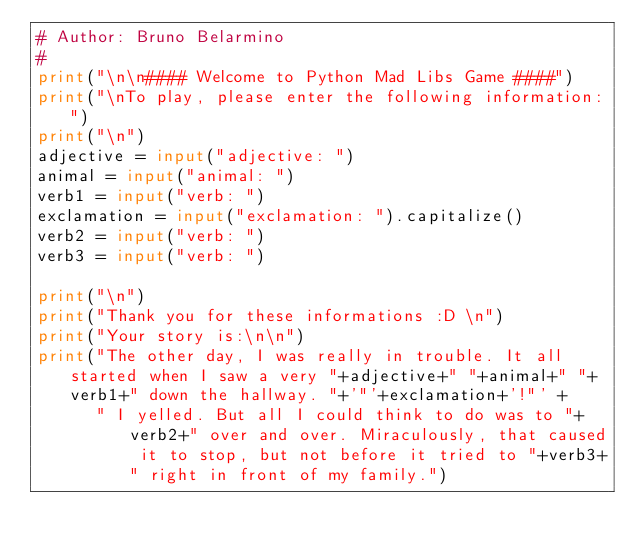<code> <loc_0><loc_0><loc_500><loc_500><_Python_># Author: Bruno Belarmino
#
print("\n\n#### Welcome to Python Mad Libs Game ####")
print("\nTo play, please enter the following information:")
print("\n")
adjective = input("adjective: ")
animal = input("animal: ")
verb1 = input("verb: ")
exclamation = input("exclamation: ").capitalize()
verb2 = input("verb: ")
verb3 = input("verb: ")

print("\n")
print("Thank you for these informations :D \n")
print("Your story is:\n\n")
print("The other day, I was really in trouble. It all started when I saw a very "+adjective+" "+animal+" "+verb1+" down the hallway. "+'"'+exclamation+'!"' +
      " I yelled. But all I could think to do was to "+verb2+" over and over. Miraculously, that caused it to stop, but not before it tried to "+verb3+" right in front of my family.")
</code> 